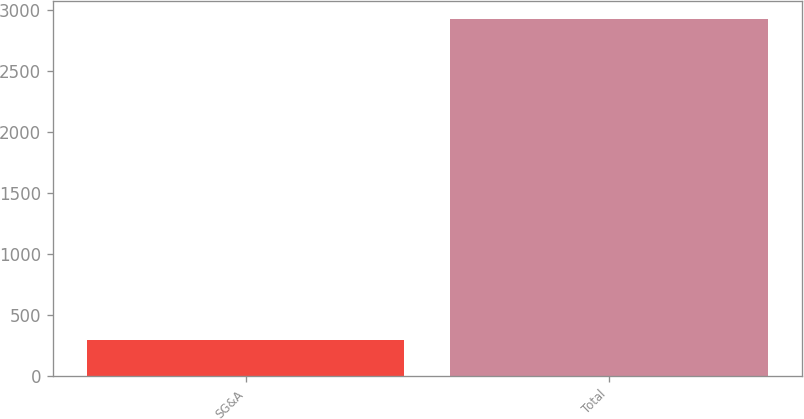Convert chart. <chart><loc_0><loc_0><loc_500><loc_500><bar_chart><fcel>SG&A<fcel>Total<nl><fcel>294<fcel>2927<nl></chart> 